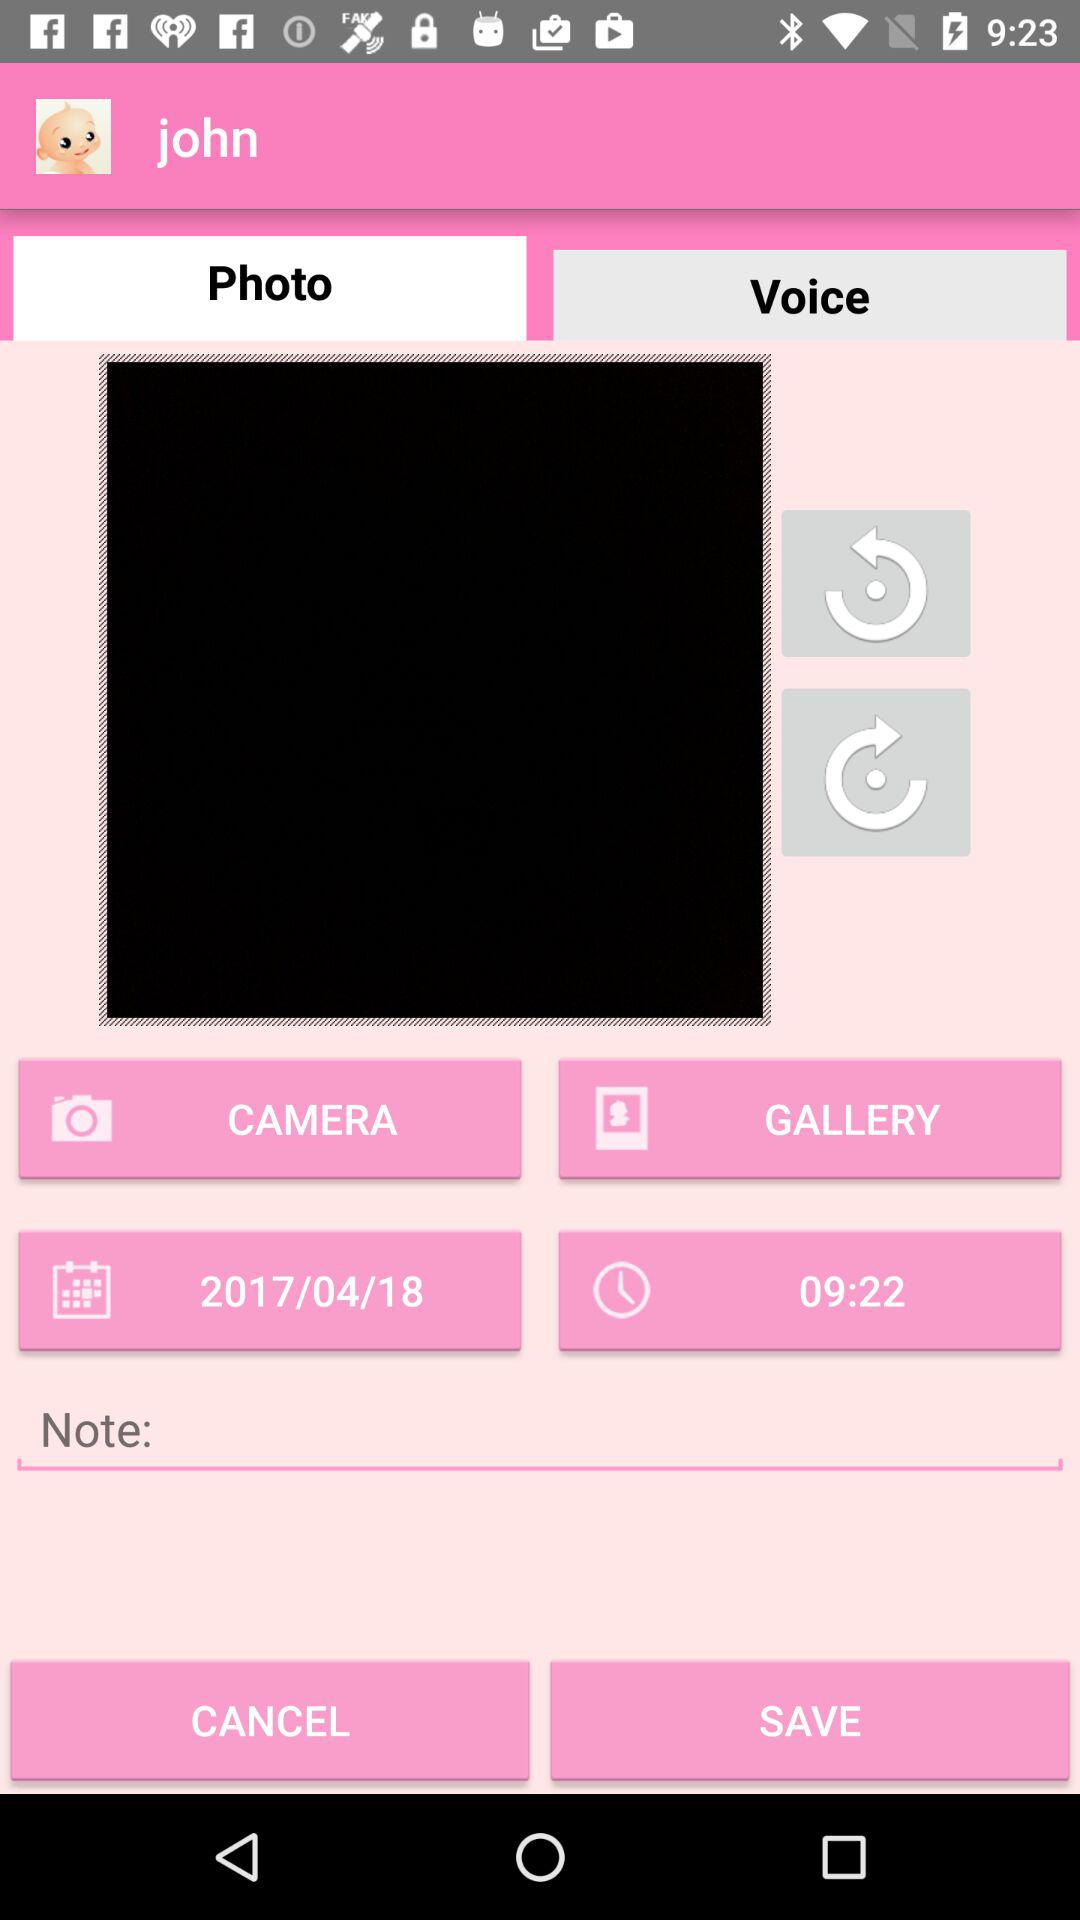Which tab has been selected? The tab "Photo" has been selected. 